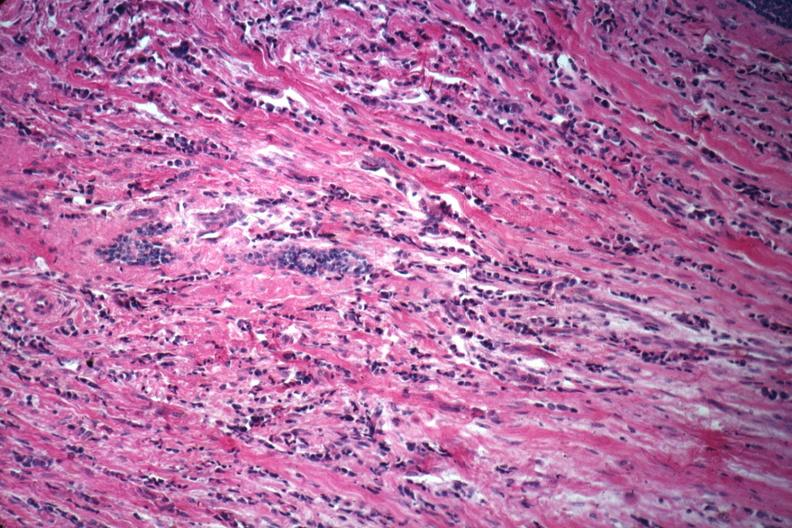does cachexia show good example of poorly differentiated infiltrating ductal carcinoma?
Answer the question using a single word or phrase. No 